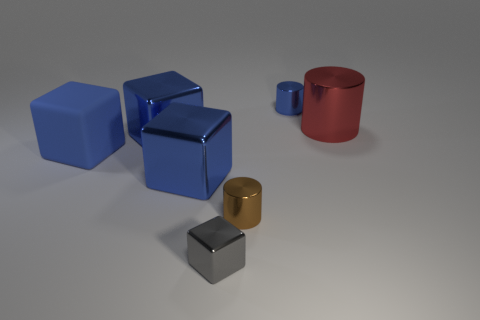What is the material of the other tiny object that is the same color as the rubber thing?
Offer a very short reply. Metal. Are there any large shiny blocks of the same color as the rubber cube?
Your answer should be compact. Yes. Is there another matte object of the same shape as the blue rubber thing?
Your response must be concise. No. What number of other objects are the same color as the big matte object?
Give a very brief answer. 3. Is the number of blue metallic cylinders in front of the brown shiny cylinder less than the number of blue rubber things?
Give a very brief answer. Yes. How many big red shiny objects are there?
Your answer should be compact. 1. What number of blue blocks are the same material as the big red cylinder?
Give a very brief answer. 2. How many things are either metal things that are in front of the matte block or large blue cubes?
Offer a terse response. 5. Is the number of big blue metallic things on the right side of the small blue cylinder less than the number of brown cylinders right of the small gray metallic block?
Give a very brief answer. Yes. There is a large red metal thing; are there any big red metallic cylinders behind it?
Provide a succinct answer. No. 